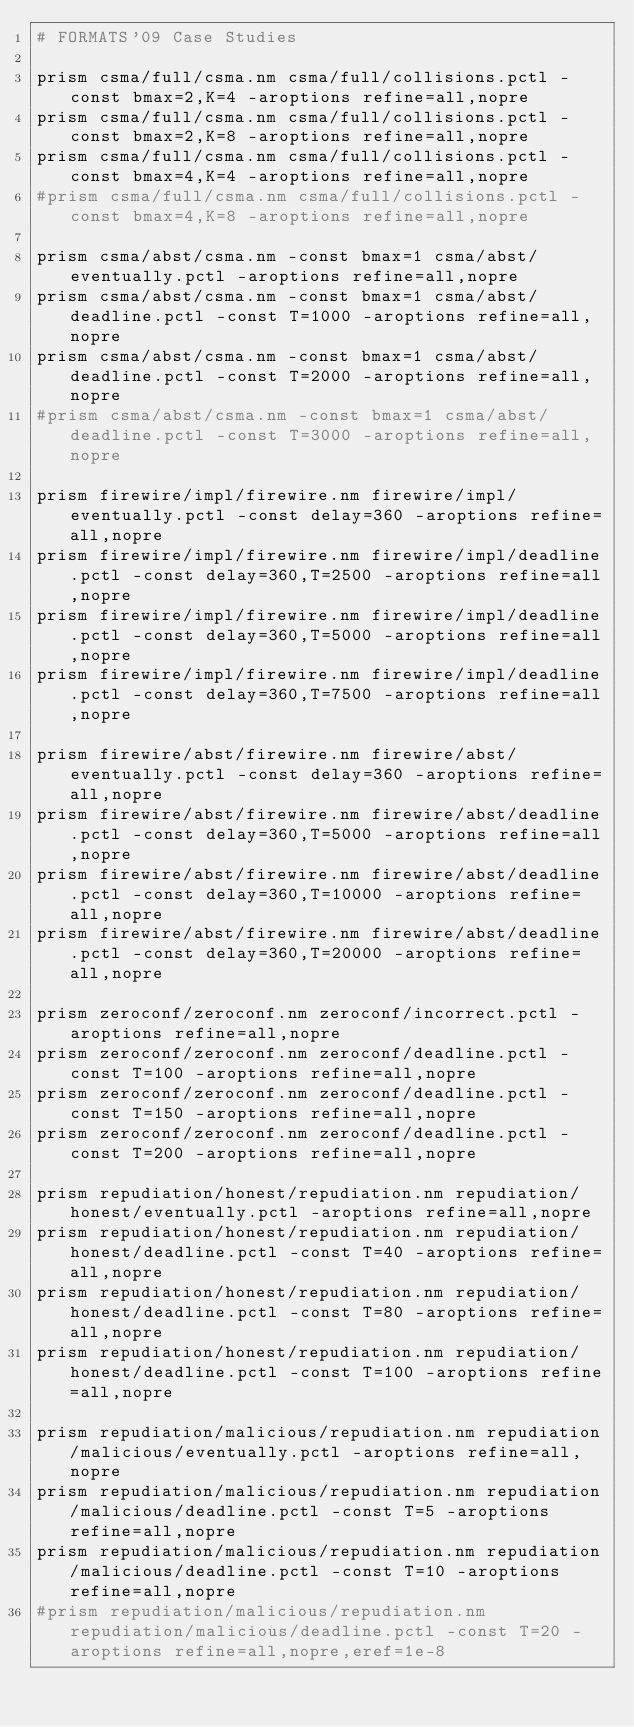Convert code to text. <code><loc_0><loc_0><loc_500><loc_500><_Bash_># FORMATS'09 Case Studies

prism csma/full/csma.nm csma/full/collisions.pctl -const bmax=2,K=4 -aroptions refine=all,nopre
prism csma/full/csma.nm csma/full/collisions.pctl -const bmax=2,K=8 -aroptions refine=all,nopre
prism csma/full/csma.nm csma/full/collisions.pctl -const bmax=4,K=4 -aroptions refine=all,nopre
#prism csma/full/csma.nm csma/full/collisions.pctl -const bmax=4,K=8 -aroptions refine=all,nopre

prism csma/abst/csma.nm -const bmax=1 csma/abst/eventually.pctl -aroptions refine=all,nopre
prism csma/abst/csma.nm -const bmax=1 csma/abst/deadline.pctl -const T=1000 -aroptions refine=all,nopre
prism csma/abst/csma.nm -const bmax=1 csma/abst/deadline.pctl -const T=2000 -aroptions refine=all,nopre
#prism csma/abst/csma.nm -const bmax=1 csma/abst/deadline.pctl -const T=3000 -aroptions refine=all,nopre

prism firewire/impl/firewire.nm firewire/impl/eventually.pctl -const delay=360 -aroptions refine=all,nopre
prism firewire/impl/firewire.nm firewire/impl/deadline.pctl -const delay=360,T=2500 -aroptions refine=all,nopre
prism firewire/impl/firewire.nm firewire/impl/deadline.pctl -const delay=360,T=5000 -aroptions refine=all,nopre
prism firewire/impl/firewire.nm firewire/impl/deadline.pctl -const delay=360,T=7500 -aroptions refine=all,nopre

prism firewire/abst/firewire.nm firewire/abst/eventually.pctl -const delay=360 -aroptions refine=all,nopre
prism firewire/abst/firewire.nm firewire/abst/deadline.pctl -const delay=360,T=5000 -aroptions refine=all,nopre
prism firewire/abst/firewire.nm firewire/abst/deadline.pctl -const delay=360,T=10000 -aroptions refine=all,nopre
prism firewire/abst/firewire.nm firewire/abst/deadline.pctl -const delay=360,T=20000 -aroptions refine=all,nopre

prism zeroconf/zeroconf.nm zeroconf/incorrect.pctl -aroptions refine=all,nopre
prism zeroconf/zeroconf.nm zeroconf/deadline.pctl -const T=100 -aroptions refine=all,nopre
prism zeroconf/zeroconf.nm zeroconf/deadline.pctl -const T=150 -aroptions refine=all,nopre
prism zeroconf/zeroconf.nm zeroconf/deadline.pctl -const T=200 -aroptions refine=all,nopre

prism repudiation/honest/repudiation.nm repudiation/honest/eventually.pctl -aroptions refine=all,nopre
prism repudiation/honest/repudiation.nm repudiation/honest/deadline.pctl -const T=40 -aroptions refine=all,nopre
prism repudiation/honest/repudiation.nm repudiation/honest/deadline.pctl -const T=80 -aroptions refine=all,nopre
prism repudiation/honest/repudiation.nm repudiation/honest/deadline.pctl -const T=100 -aroptions refine=all,nopre

prism repudiation/malicious/repudiation.nm repudiation/malicious/eventually.pctl -aroptions refine=all,nopre
prism repudiation/malicious/repudiation.nm repudiation/malicious/deadline.pctl -const T=5 -aroptions refine=all,nopre
prism repudiation/malicious/repudiation.nm repudiation/malicious/deadline.pctl -const T=10 -aroptions refine=all,nopre
#prism repudiation/malicious/repudiation.nm repudiation/malicious/deadline.pctl -const T=20 -aroptions refine=all,nopre,eref=1e-8
</code> 